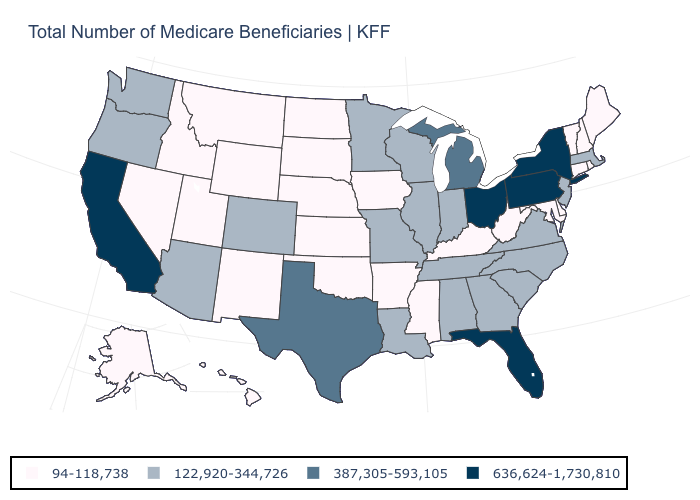What is the value of Delaware?
Keep it brief. 94-118,738. What is the value of Ohio?
Answer briefly. 636,624-1,730,810. Name the states that have a value in the range 122,920-344,726?
Concise answer only. Alabama, Arizona, Colorado, Georgia, Illinois, Indiana, Louisiana, Massachusetts, Minnesota, Missouri, New Jersey, North Carolina, Oregon, South Carolina, Tennessee, Virginia, Washington, Wisconsin. Name the states that have a value in the range 122,920-344,726?
Quick response, please. Alabama, Arizona, Colorado, Georgia, Illinois, Indiana, Louisiana, Massachusetts, Minnesota, Missouri, New Jersey, North Carolina, Oregon, South Carolina, Tennessee, Virginia, Washington, Wisconsin. What is the lowest value in the MidWest?
Keep it brief. 94-118,738. Name the states that have a value in the range 387,305-593,105?
Write a very short answer. Michigan, Texas. What is the value of Iowa?
Quick response, please. 94-118,738. What is the highest value in the Northeast ?
Be succinct. 636,624-1,730,810. Name the states that have a value in the range 636,624-1,730,810?
Answer briefly. California, Florida, New York, Ohio, Pennsylvania. What is the lowest value in the USA?
Quick response, please. 94-118,738. What is the lowest value in the MidWest?
Keep it brief. 94-118,738. What is the highest value in the Northeast ?
Answer briefly. 636,624-1,730,810. What is the value of Iowa?
Give a very brief answer. 94-118,738. What is the value of North Carolina?
Keep it brief. 122,920-344,726. What is the value of Florida?
Keep it brief. 636,624-1,730,810. 